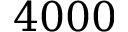Convert formula to latex. <formula><loc_0><loc_0><loc_500><loc_500>4 0 0 0</formula> 